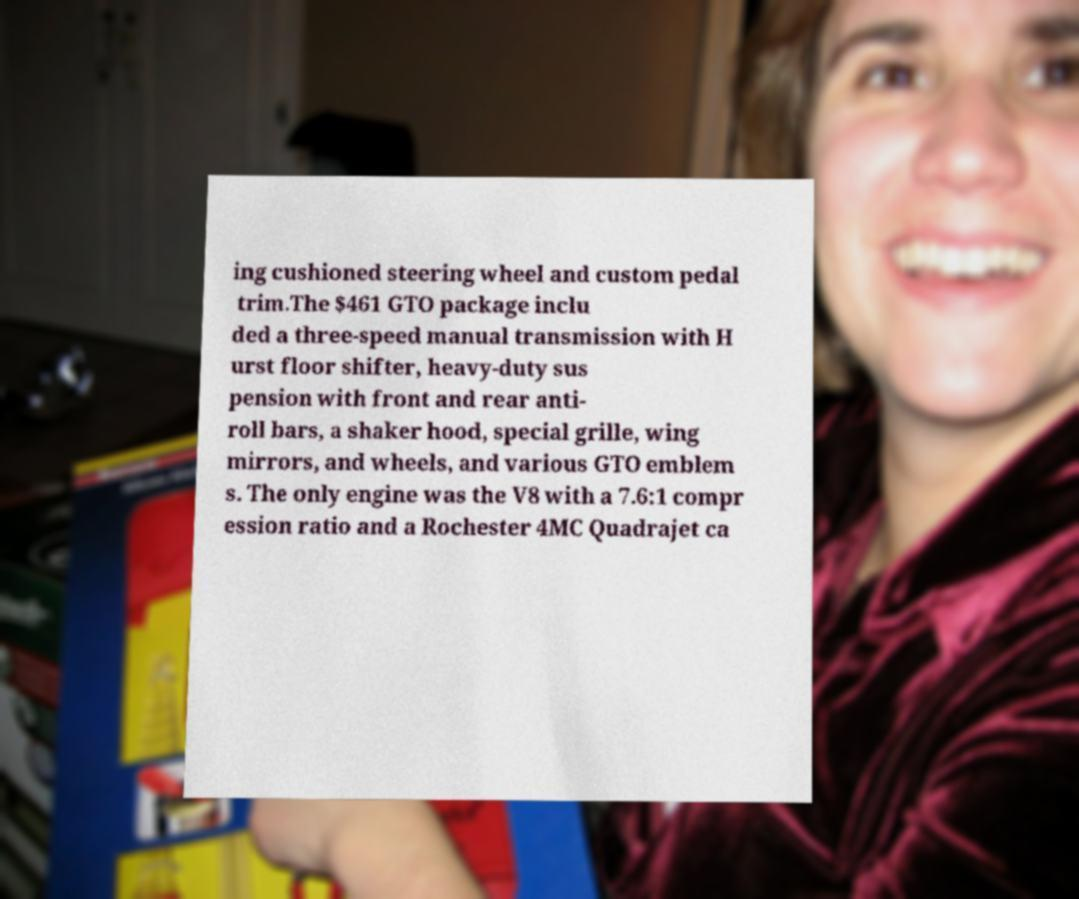For documentation purposes, I need the text within this image transcribed. Could you provide that? ing cushioned steering wheel and custom pedal trim.The $461 GTO package inclu ded a three-speed manual transmission with H urst floor shifter, heavy-duty sus pension with front and rear anti- roll bars, a shaker hood, special grille, wing mirrors, and wheels, and various GTO emblem s. The only engine was the V8 with a 7.6:1 compr ession ratio and a Rochester 4MC Quadrajet ca 